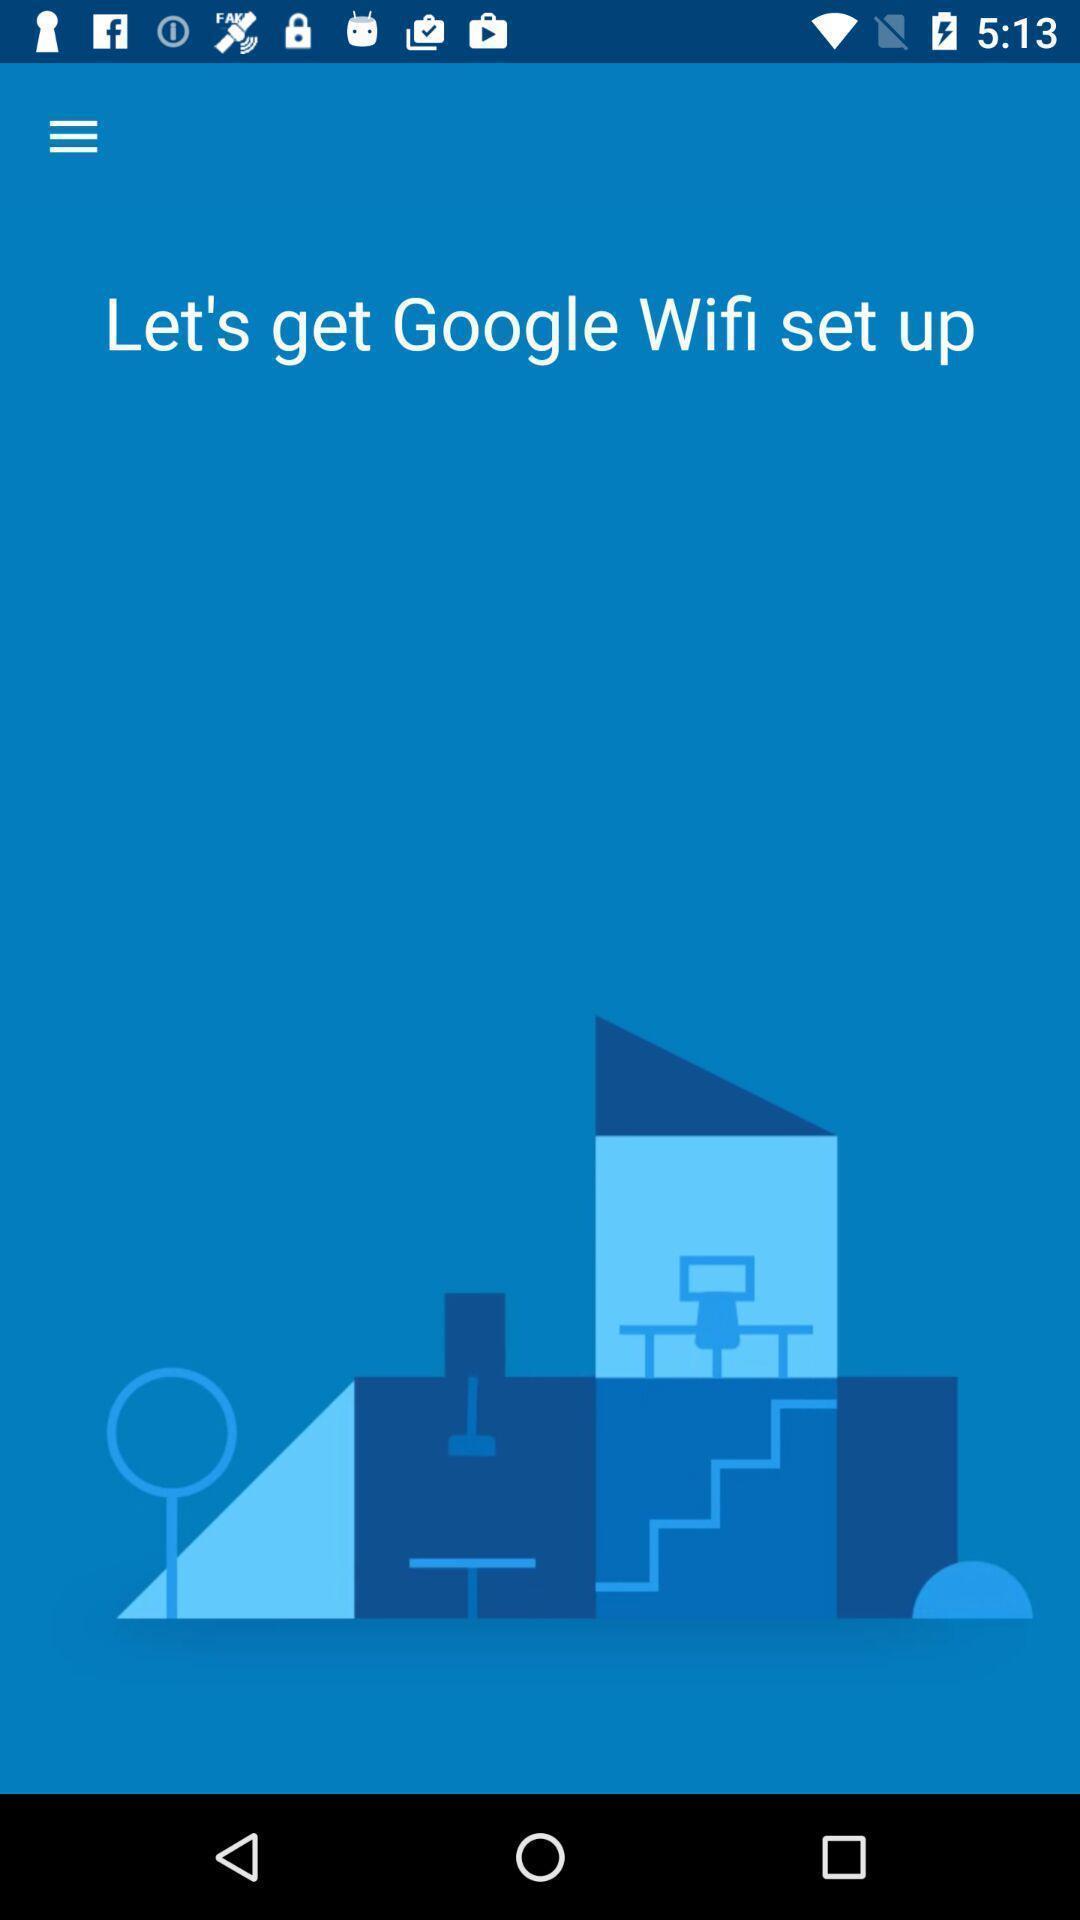What can you discern from this picture? Welcome screen of an page. 